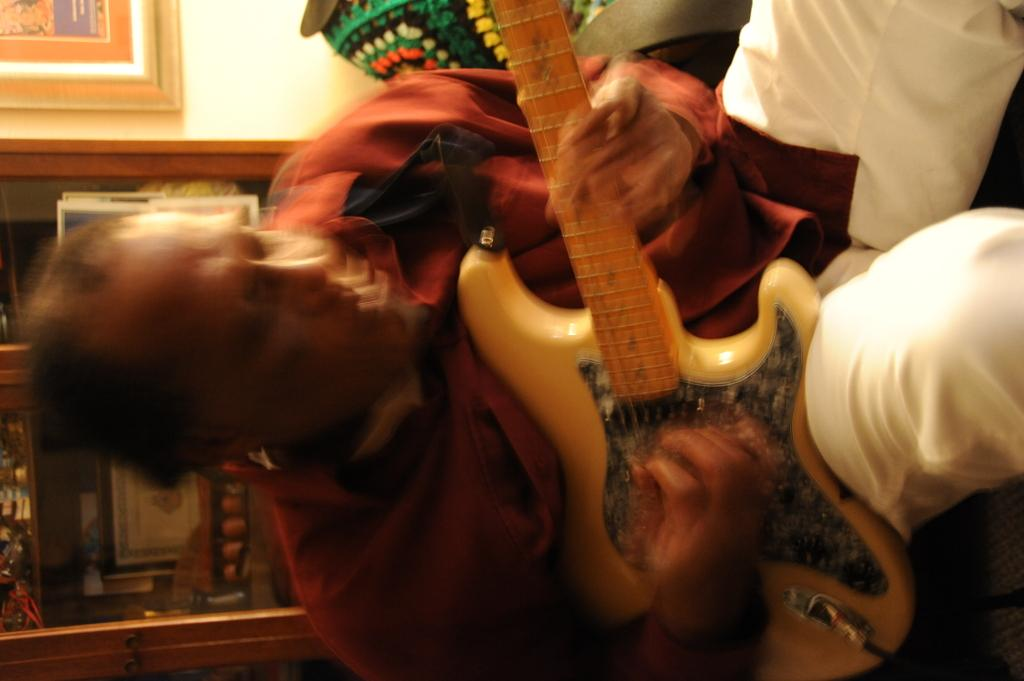What is the man in the image doing? The man is playing a guitar in the image. How is the man playing the guitar? The man is using his hands to play the guitar. What can be seen in the background of the image? There is a wall in the background of the image. What is on the wall in the image? There is a cupboard on the wall. What is inside the cupboard? There are objects in the cupboard. What type of payment does the carpenter receive for his work in the image? There is no carpenter present in the image, nor is there any indication of payment being made or received. 